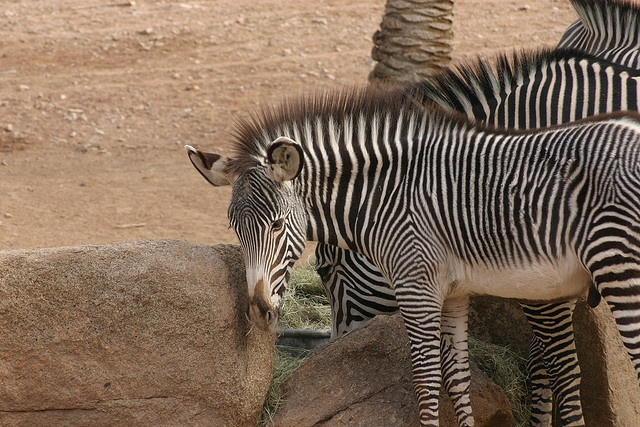Describe the objects in this image and their specific colors. I can see zebra in tan, black, gray, and darkgray tones, zebra in tan, black, gray, and darkgray tones, and zebra in tan, black, gray, and darkgray tones in this image. 